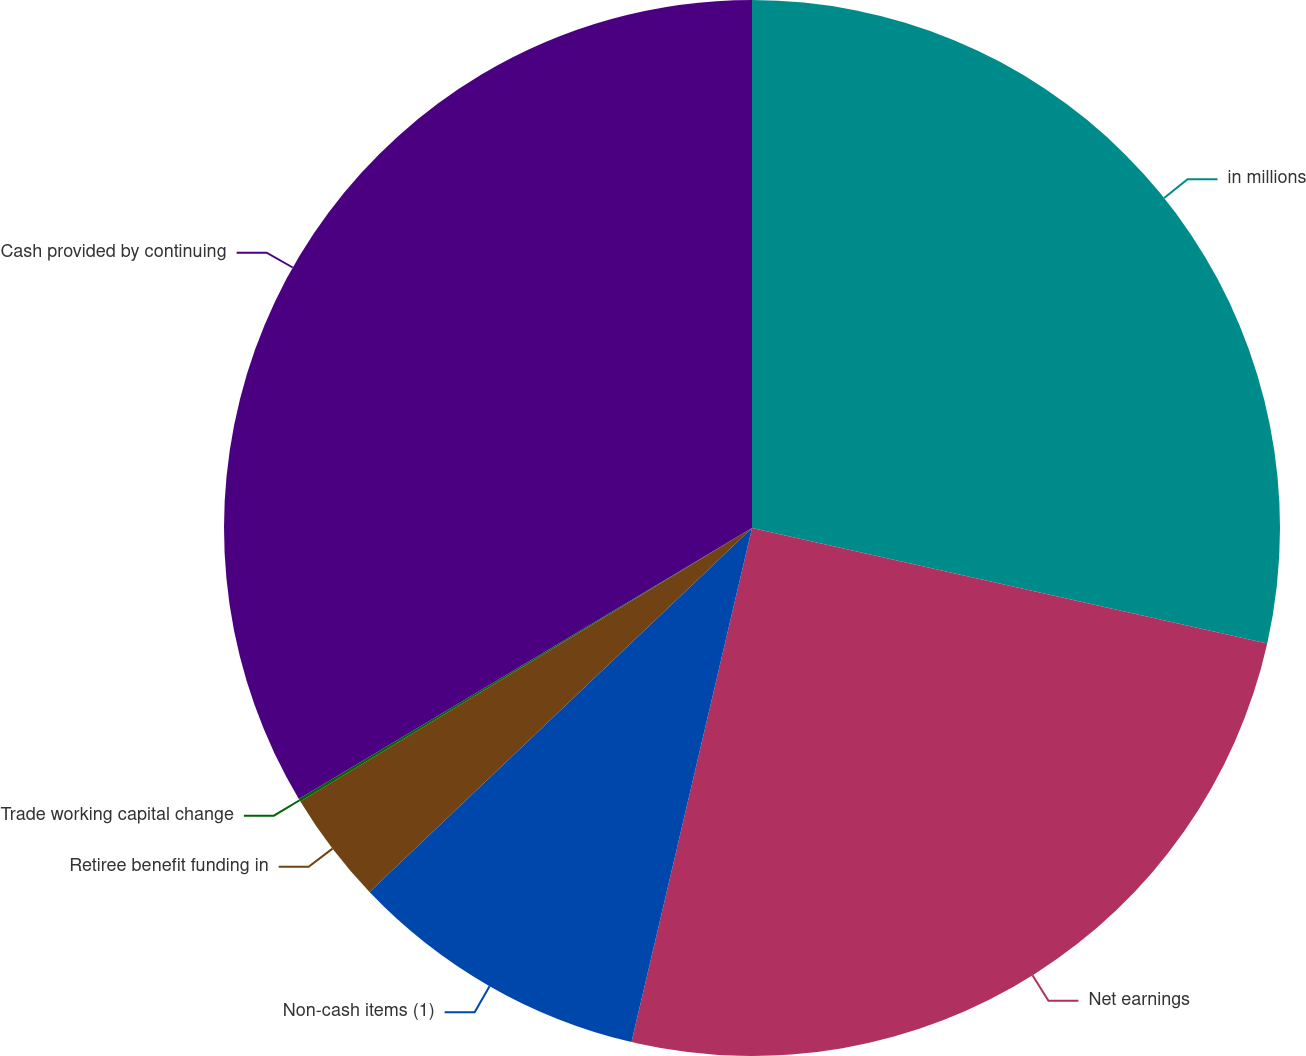Convert chart. <chart><loc_0><loc_0><loc_500><loc_500><pie_chart><fcel>in millions<fcel>Net earnings<fcel>Non-cash items (1)<fcel>Retiree benefit funding in<fcel>Trade working capital change<fcel>Cash provided by continuing<nl><fcel>28.51%<fcel>25.16%<fcel>9.23%<fcel>3.44%<fcel>0.09%<fcel>33.58%<nl></chart> 